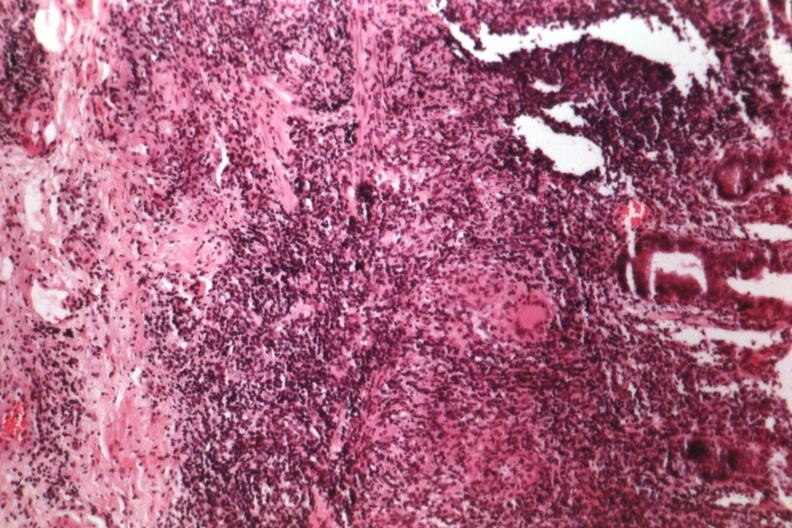what is present?
Answer the question using a single word or phrase. Gastrointestinal 